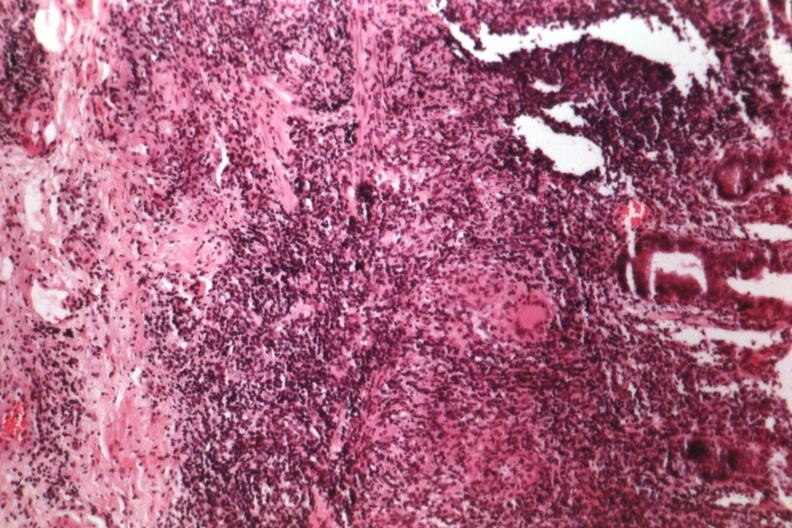what is present?
Answer the question using a single word or phrase. Gastrointestinal 